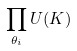<formula> <loc_0><loc_0><loc_500><loc_500>\prod _ { \theta _ { i } } U ( K )</formula> 